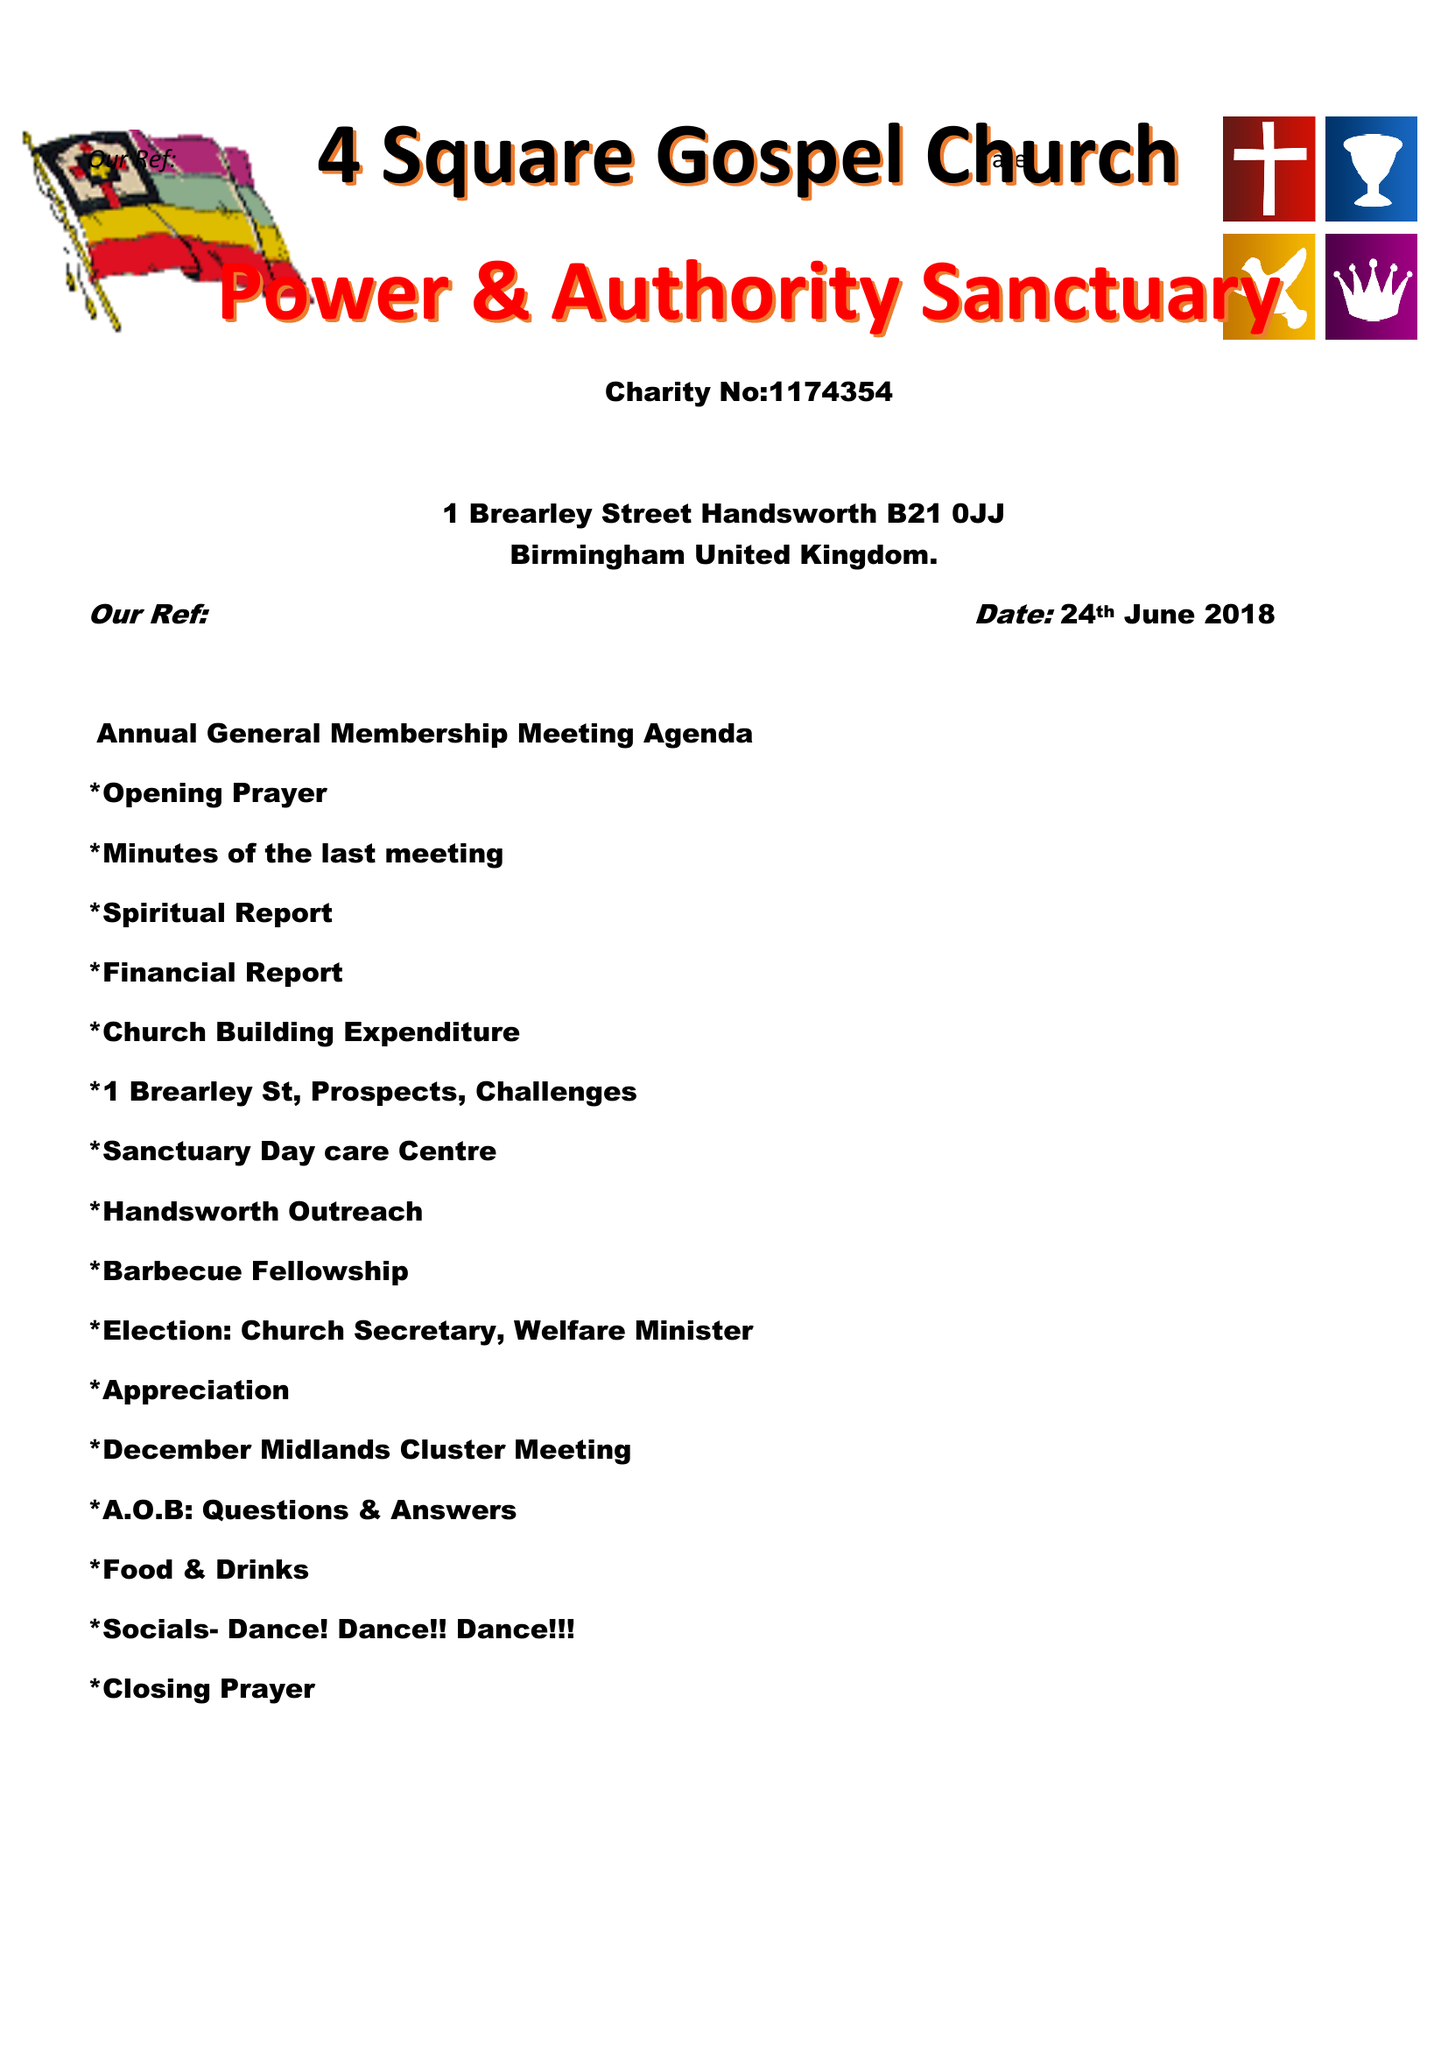What is the value for the income_annually_in_british_pounds?
Answer the question using a single word or phrase. 11885.00 